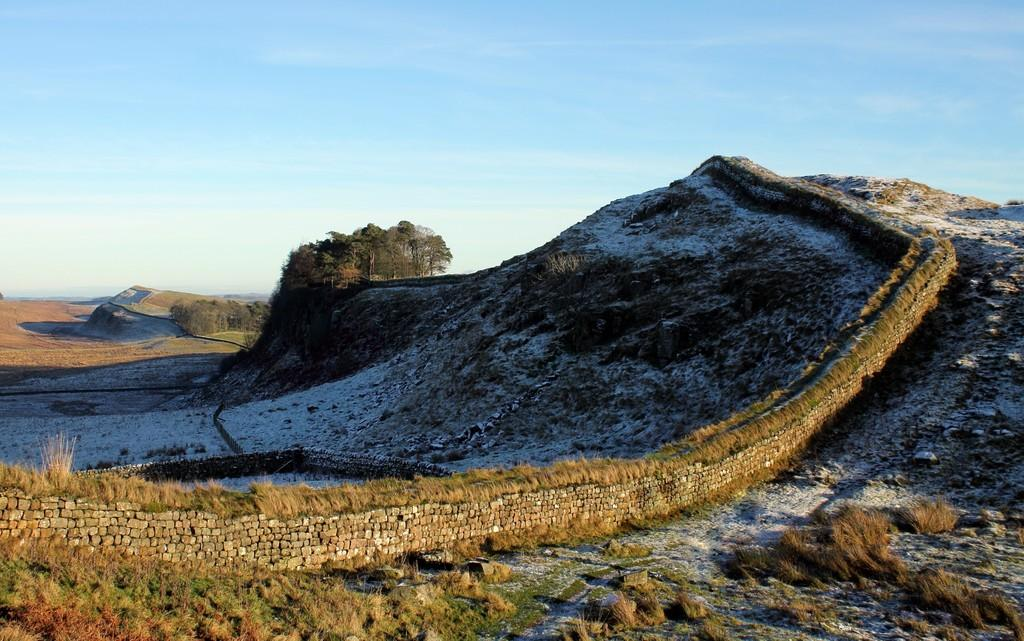What type of landscape can be seen in the image? There are hills in the image, which suggests a hilly landscape. What type of vegetation is present in the image? There is grass and trees in the image. What structure can be seen in the image? There is a wall in the image. What is visible in the background of the image? The sky is visible in the image, and clouds are present in the sky. Where is the birth certificate located in the image? There is no birth certificate present in the image. What type of change can be seen happening to the trees in the image? There is no change happening to the trees in the image; they are stationary. 